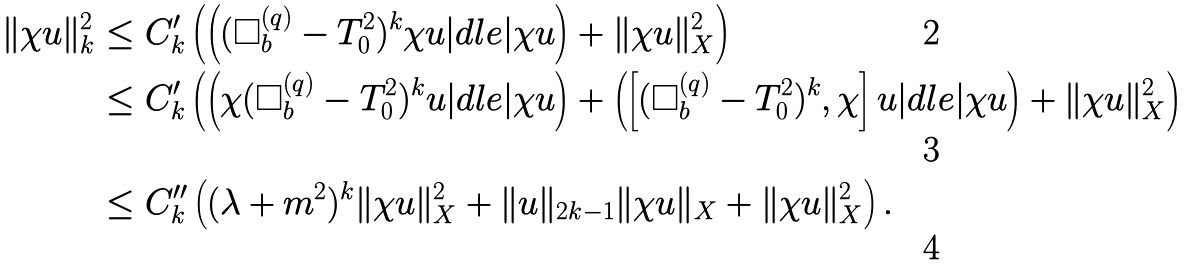<formula> <loc_0><loc_0><loc_500><loc_500>\| \chi u \| _ { k } ^ { 2 } & \leq C _ { k } ^ { \prime } \left ( \left ( ( \Box ^ { ( q ) } _ { b } - T _ { 0 } ^ { 2 } ) ^ { k } \chi u | d l e | \chi u \right ) + \| \chi u \| _ { X } ^ { 2 } \right ) \\ & \leq C _ { k } ^ { \prime } \left ( \left ( \chi ( \Box _ { b } ^ { ( q ) } - T _ { 0 } ^ { 2 } ) ^ { k } u | d l e | \chi u \right ) + \left ( \left [ ( \Box _ { b } ^ { ( q ) } - T _ { 0 } ^ { 2 } ) ^ { k } , \chi \right ] u | d l e | \chi u \right ) + \| \chi u \| _ { X } ^ { 2 } \right ) \\ & \leq C _ { k } ^ { \prime \prime } \left ( ( \lambda + m ^ { 2 } ) ^ { k } \| \chi u \| _ { X } ^ { 2 } + \| u \| _ { 2 k - 1 } \| \chi u \| _ { X } + \| \chi u \| _ { X } ^ { 2 } \right ) .</formula> 